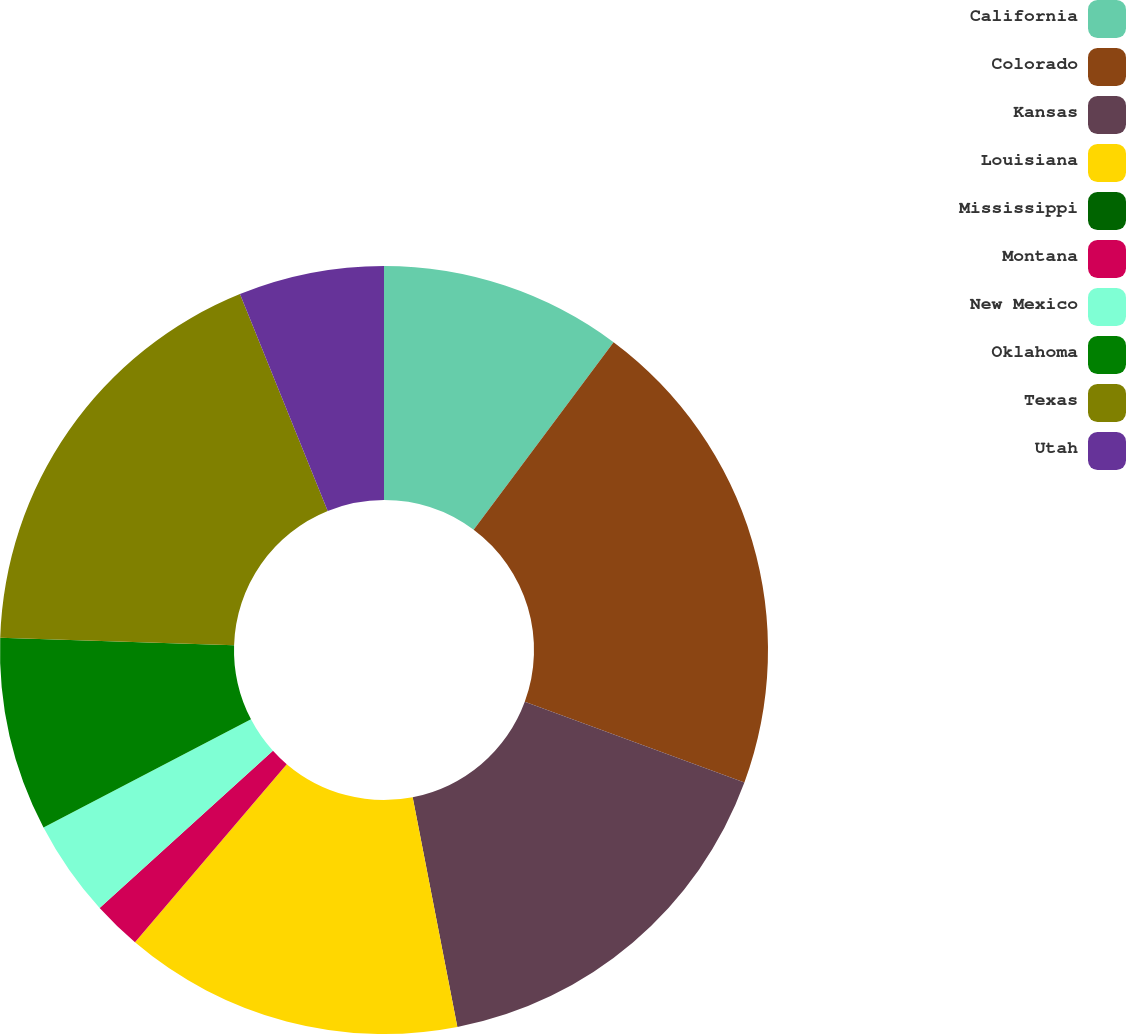<chart> <loc_0><loc_0><loc_500><loc_500><pie_chart><fcel>California<fcel>Colorado<fcel>Kansas<fcel>Louisiana<fcel>Mississippi<fcel>Montana<fcel>New Mexico<fcel>Oklahoma<fcel>Texas<fcel>Utah<nl><fcel>10.2%<fcel>20.41%<fcel>16.33%<fcel>14.29%<fcel>0.0%<fcel>2.04%<fcel>4.08%<fcel>8.16%<fcel>18.37%<fcel>6.12%<nl></chart> 